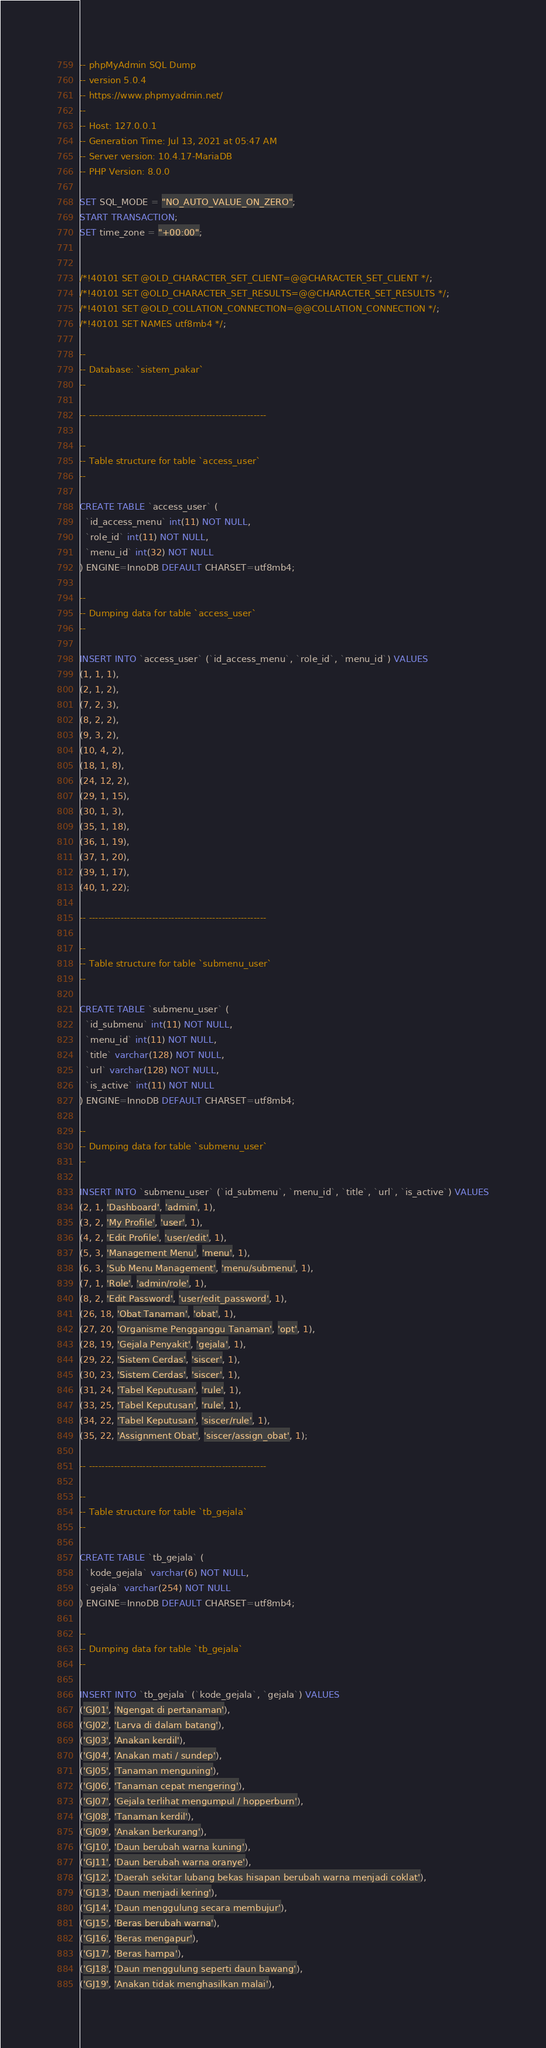<code> <loc_0><loc_0><loc_500><loc_500><_SQL_>-- phpMyAdmin SQL Dump
-- version 5.0.4
-- https://www.phpmyadmin.net/
--
-- Host: 127.0.0.1
-- Generation Time: Jul 13, 2021 at 05:47 AM
-- Server version: 10.4.17-MariaDB
-- PHP Version: 8.0.0

SET SQL_MODE = "NO_AUTO_VALUE_ON_ZERO";
START TRANSACTION;
SET time_zone = "+00:00";


/*!40101 SET @OLD_CHARACTER_SET_CLIENT=@@CHARACTER_SET_CLIENT */;
/*!40101 SET @OLD_CHARACTER_SET_RESULTS=@@CHARACTER_SET_RESULTS */;
/*!40101 SET @OLD_COLLATION_CONNECTION=@@COLLATION_CONNECTION */;
/*!40101 SET NAMES utf8mb4 */;

--
-- Database: `sistem_pakar`
--

-- --------------------------------------------------------

--
-- Table structure for table `access_user`
--

CREATE TABLE `access_user` (
  `id_access_menu` int(11) NOT NULL,
  `role_id` int(11) NOT NULL,
  `menu_id` int(32) NOT NULL
) ENGINE=InnoDB DEFAULT CHARSET=utf8mb4;

--
-- Dumping data for table `access_user`
--

INSERT INTO `access_user` (`id_access_menu`, `role_id`, `menu_id`) VALUES
(1, 1, 1),
(2, 1, 2),
(7, 2, 3),
(8, 2, 2),
(9, 3, 2),
(10, 4, 2),
(18, 1, 8),
(24, 12, 2),
(29, 1, 15),
(30, 1, 3),
(35, 1, 18),
(36, 1, 19),
(37, 1, 20),
(39, 1, 17),
(40, 1, 22);

-- --------------------------------------------------------

--
-- Table structure for table `submenu_user`
--

CREATE TABLE `submenu_user` (
  `id_submenu` int(11) NOT NULL,
  `menu_id` int(11) NOT NULL,
  `title` varchar(128) NOT NULL,
  `url` varchar(128) NOT NULL,
  `is_active` int(11) NOT NULL
) ENGINE=InnoDB DEFAULT CHARSET=utf8mb4;

--
-- Dumping data for table `submenu_user`
--

INSERT INTO `submenu_user` (`id_submenu`, `menu_id`, `title`, `url`, `is_active`) VALUES
(2, 1, 'Dashboard', 'admin', 1),
(3, 2, 'My Profile', 'user', 1),
(4, 2, 'Edit Profile', 'user/edit', 1),
(5, 3, 'Management Menu', 'menu', 1),
(6, 3, 'Sub Menu Management', 'menu/submenu', 1),
(7, 1, 'Role', 'admin/role', 1),
(8, 2, 'Edit Password', 'user/edit_password', 1),
(26, 18, 'Obat Tanaman', 'obat', 1),
(27, 20, 'Organisme Pengganggu Tanaman', 'opt', 1),
(28, 19, 'Gejala Penyakit', 'gejala', 1),
(29, 22, 'Sistem Cerdas', 'siscer', 1),
(30, 23, 'Sistem Cerdas', 'siscer', 1),
(31, 24, 'Tabel Keputusan', 'rule', 1),
(33, 25, 'Tabel Keputusan', 'rule', 1),
(34, 22, 'Tabel Keputusan', 'siscer/rule', 1),
(35, 22, 'Assignment Obat', 'siscer/assign_obat', 1);

-- --------------------------------------------------------

--
-- Table structure for table `tb_gejala`
--

CREATE TABLE `tb_gejala` (
  `kode_gejala` varchar(6) NOT NULL,
  `gejala` varchar(254) NOT NULL
) ENGINE=InnoDB DEFAULT CHARSET=utf8mb4;

--
-- Dumping data for table `tb_gejala`
--

INSERT INTO `tb_gejala` (`kode_gejala`, `gejala`) VALUES
('GJ01', 'Ngengat di pertanaman'),
('GJ02', 'Larva di dalam batang'),
('GJ03', 'Anakan kerdil'),
('GJ04', 'Anakan mati / sundep'),
('GJ05', 'Tanaman menguning'),
('GJ06', 'Tanaman cepat mengering'),
('GJ07', 'Gejala terlihat mengumpul / hopperburn'),
('GJ08', 'Tanaman kerdil'),
('GJ09', 'Anakan berkurang'),
('GJ10', 'Daun berubah warna kuning'),
('GJ11', 'Daun berubah warna oranye'),
('GJ12', 'Daerah sekitar lubang bekas hisapan berubah warna menjadi coklat'),
('GJ13', 'Daun menjadi kering'),
('GJ14', 'Daun menggulung secara membujur'),
('GJ15', 'Beras berubah warna'),
('GJ16', 'Beras mengapur'),
('GJ17', 'Beras hampa'),
('GJ18', 'Daun menggulung seperti daun bawang'),
('GJ19', 'Anakan tidak menghasilkan malai'),</code> 